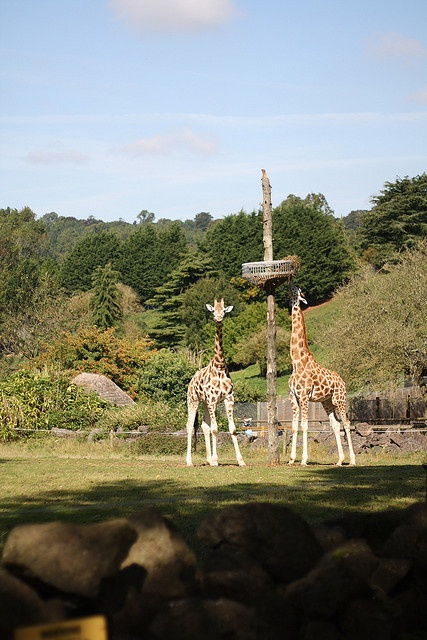Describe the objects in this image and their specific colors. I can see giraffe in lightblue, beige, and tan tones and giraffe in lightblue, ivory, tan, and olive tones in this image. 